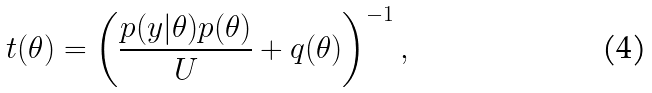Convert formula to latex. <formula><loc_0><loc_0><loc_500><loc_500>t ( \theta ) = \left ( \frac { p ( y | \theta ) p ( \theta ) } { U } + q ( \theta ) \right ) ^ { - 1 } ,</formula> 